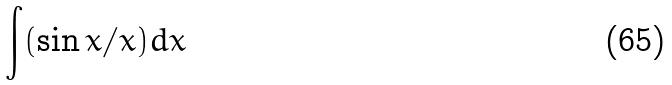<formula> <loc_0><loc_0><loc_500><loc_500>\int ( \sin x / x ) d x</formula> 